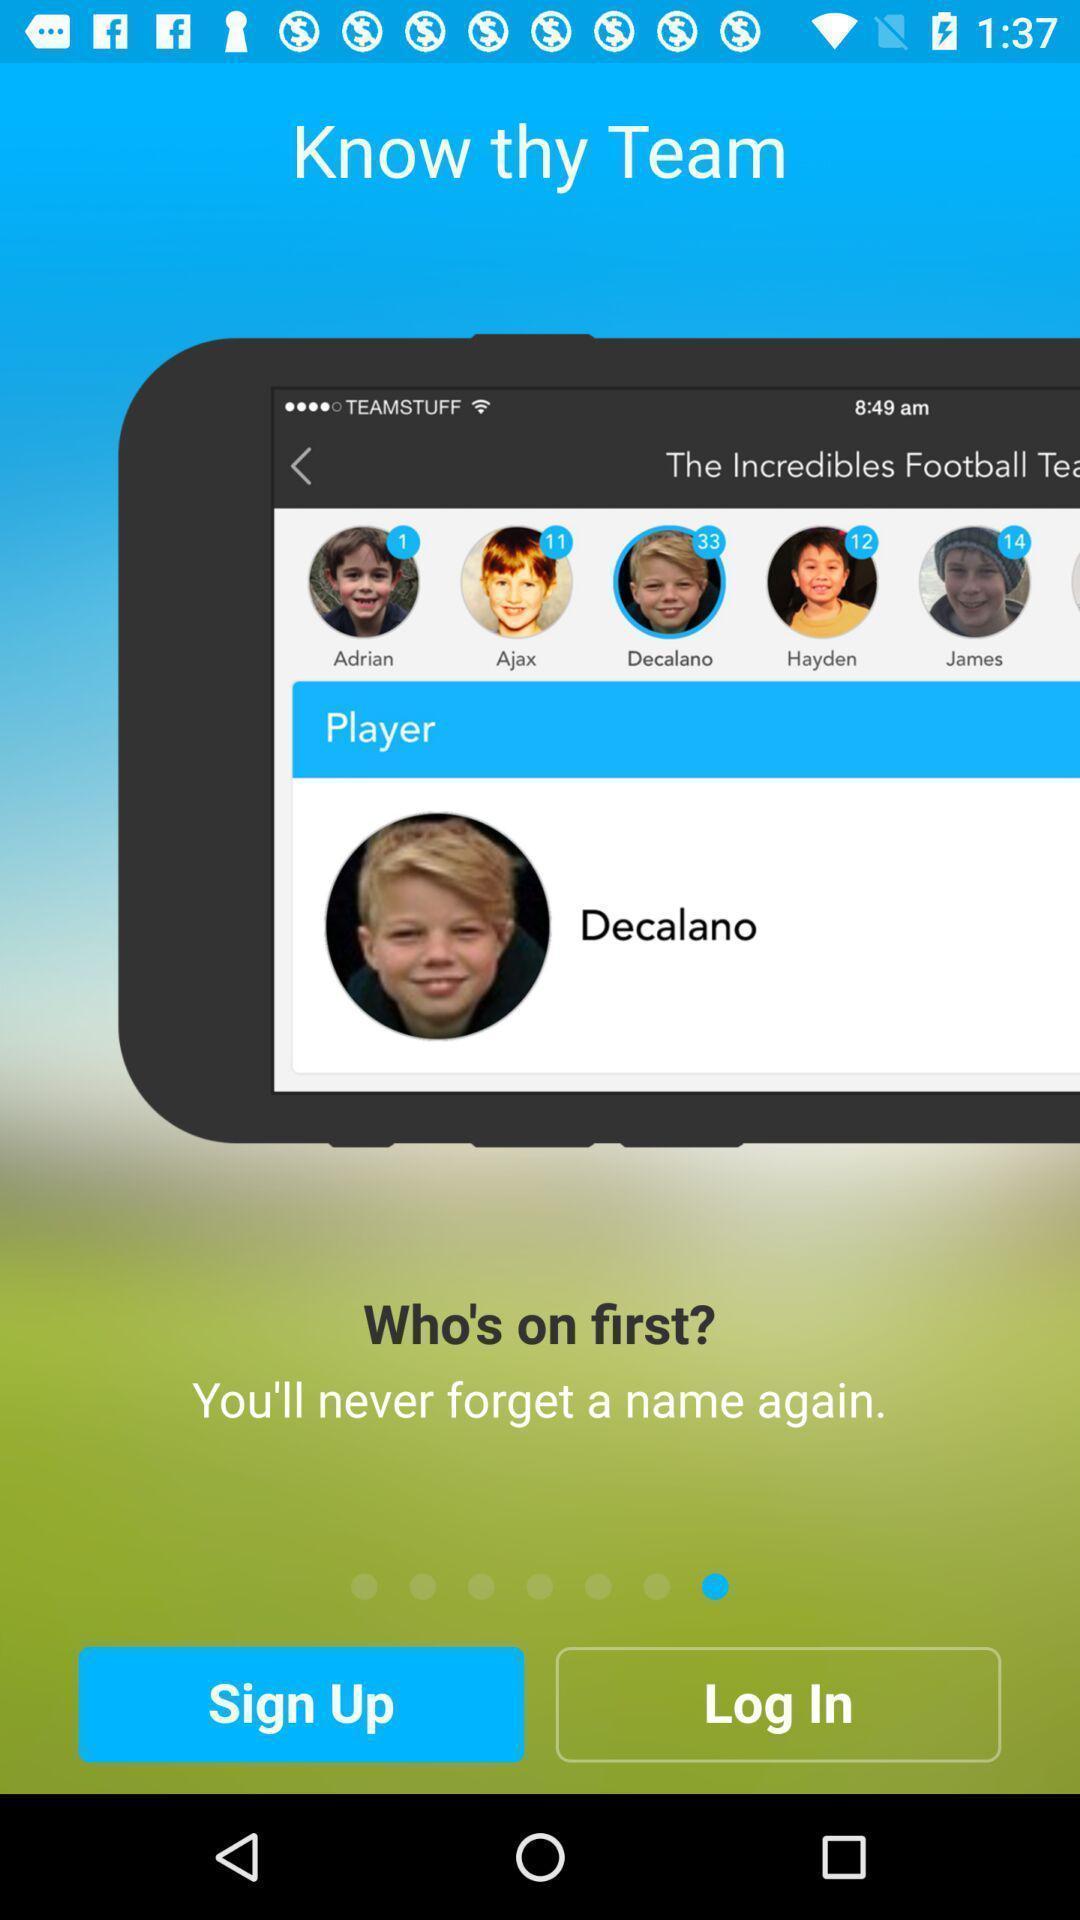Tell me about the visual elements in this screen capture. Sign up page. 